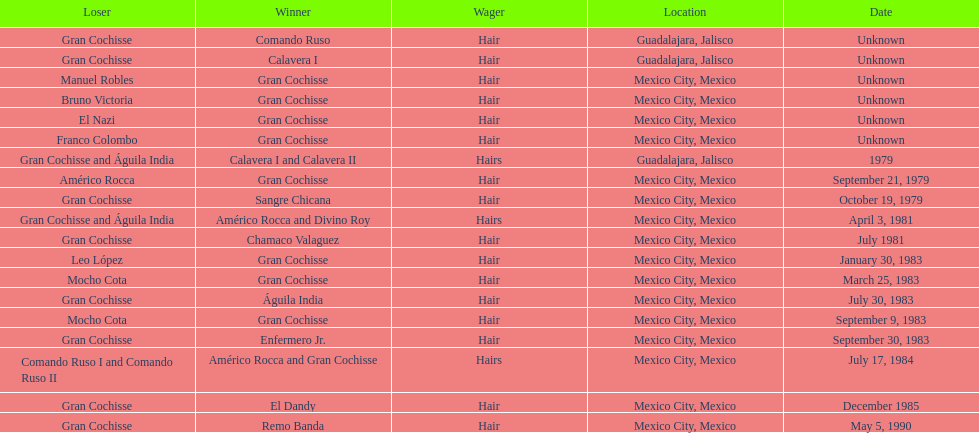When did bruno victoria lose his first game? Unknown. 